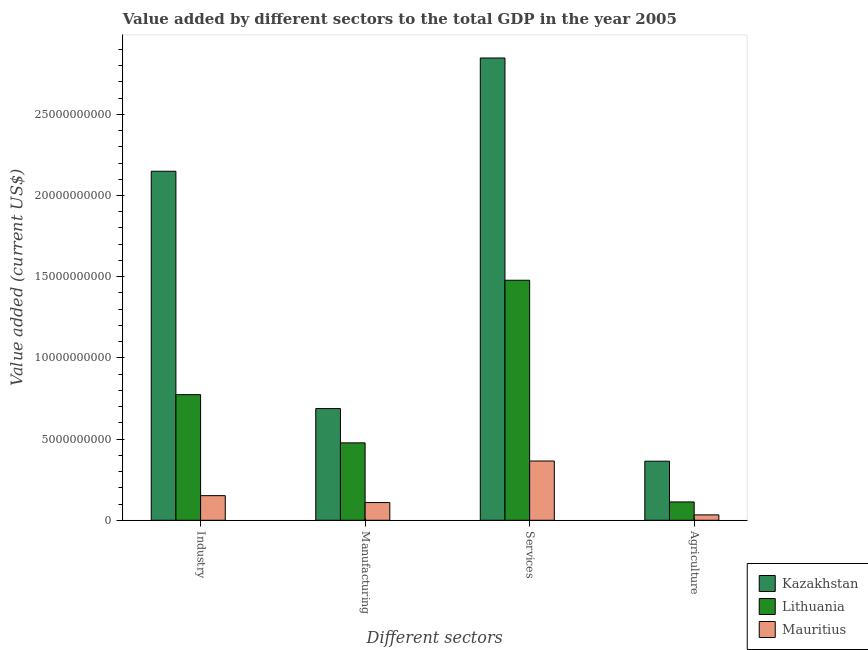Are the number of bars per tick equal to the number of legend labels?
Your answer should be very brief. Yes. Are the number of bars on each tick of the X-axis equal?
Ensure brevity in your answer.  Yes. What is the label of the 2nd group of bars from the left?
Keep it short and to the point. Manufacturing. What is the value added by manufacturing sector in Mauritius?
Keep it short and to the point. 1.09e+09. Across all countries, what is the maximum value added by services sector?
Provide a succinct answer. 2.85e+1. Across all countries, what is the minimum value added by services sector?
Give a very brief answer. 3.65e+09. In which country was the value added by industrial sector maximum?
Offer a very short reply. Kazakhstan. In which country was the value added by services sector minimum?
Provide a short and direct response. Mauritius. What is the total value added by services sector in the graph?
Your answer should be very brief. 4.69e+1. What is the difference between the value added by agricultural sector in Mauritius and that in Lithuania?
Provide a short and direct response. -7.98e+08. What is the difference between the value added by agricultural sector in Lithuania and the value added by industrial sector in Kazakhstan?
Offer a very short reply. -2.04e+1. What is the average value added by industrial sector per country?
Your answer should be compact. 1.02e+1. What is the difference between the value added by agricultural sector and value added by services sector in Kazakhstan?
Provide a succinct answer. -2.48e+1. In how many countries, is the value added by agricultural sector greater than 19000000000 US$?
Your response must be concise. 0. What is the ratio of the value added by agricultural sector in Lithuania to that in Mauritius?
Keep it short and to the point. 3.4. Is the value added by agricultural sector in Kazakhstan less than that in Lithuania?
Your response must be concise. No. What is the difference between the highest and the second highest value added by manufacturing sector?
Ensure brevity in your answer.  2.11e+09. What is the difference between the highest and the lowest value added by industrial sector?
Your answer should be compact. 2.00e+1. In how many countries, is the value added by manufacturing sector greater than the average value added by manufacturing sector taken over all countries?
Give a very brief answer. 2. Is the sum of the value added by agricultural sector in Mauritius and Kazakhstan greater than the maximum value added by manufacturing sector across all countries?
Give a very brief answer. No. Is it the case that in every country, the sum of the value added by services sector and value added by agricultural sector is greater than the sum of value added by industrial sector and value added by manufacturing sector?
Give a very brief answer. No. What does the 3rd bar from the left in Services represents?
Your answer should be very brief. Mauritius. What does the 3rd bar from the right in Manufacturing represents?
Offer a very short reply. Kazakhstan. Is it the case that in every country, the sum of the value added by industrial sector and value added by manufacturing sector is greater than the value added by services sector?
Give a very brief answer. No. How many bars are there?
Provide a succinct answer. 12. Are all the bars in the graph horizontal?
Your answer should be very brief. No. How many countries are there in the graph?
Provide a succinct answer. 3. Are the values on the major ticks of Y-axis written in scientific E-notation?
Provide a succinct answer. No. Does the graph contain any zero values?
Your answer should be compact. No. What is the title of the graph?
Ensure brevity in your answer.  Value added by different sectors to the total GDP in the year 2005. What is the label or title of the X-axis?
Offer a terse response. Different sectors. What is the label or title of the Y-axis?
Keep it short and to the point. Value added (current US$). What is the Value added (current US$) of Kazakhstan in Industry?
Give a very brief answer. 2.15e+1. What is the Value added (current US$) in Lithuania in Industry?
Offer a very short reply. 7.74e+09. What is the Value added (current US$) in Mauritius in Industry?
Your response must be concise. 1.52e+09. What is the Value added (current US$) of Kazakhstan in Manufacturing?
Provide a succinct answer. 6.88e+09. What is the Value added (current US$) in Lithuania in Manufacturing?
Ensure brevity in your answer.  4.77e+09. What is the Value added (current US$) in Mauritius in Manufacturing?
Provide a succinct answer. 1.09e+09. What is the Value added (current US$) of Kazakhstan in Services?
Your answer should be very brief. 2.85e+1. What is the Value added (current US$) of Lithuania in Services?
Offer a very short reply. 1.48e+1. What is the Value added (current US$) in Mauritius in Services?
Your response must be concise. 3.65e+09. What is the Value added (current US$) of Kazakhstan in Agriculture?
Provide a succinct answer. 3.64e+09. What is the Value added (current US$) in Lithuania in Agriculture?
Offer a terse response. 1.13e+09. What is the Value added (current US$) of Mauritius in Agriculture?
Your answer should be compact. 3.32e+08. Across all Different sectors, what is the maximum Value added (current US$) of Kazakhstan?
Provide a succinct answer. 2.85e+1. Across all Different sectors, what is the maximum Value added (current US$) in Lithuania?
Offer a very short reply. 1.48e+1. Across all Different sectors, what is the maximum Value added (current US$) of Mauritius?
Keep it short and to the point. 3.65e+09. Across all Different sectors, what is the minimum Value added (current US$) in Kazakhstan?
Your response must be concise. 3.64e+09. Across all Different sectors, what is the minimum Value added (current US$) in Lithuania?
Give a very brief answer. 1.13e+09. Across all Different sectors, what is the minimum Value added (current US$) in Mauritius?
Offer a very short reply. 3.32e+08. What is the total Value added (current US$) in Kazakhstan in the graph?
Your response must be concise. 6.05e+1. What is the total Value added (current US$) of Lithuania in the graph?
Make the answer very short. 2.84e+1. What is the total Value added (current US$) of Mauritius in the graph?
Your response must be concise. 6.59e+09. What is the difference between the Value added (current US$) in Kazakhstan in Industry and that in Manufacturing?
Offer a terse response. 1.46e+1. What is the difference between the Value added (current US$) in Lithuania in Industry and that in Manufacturing?
Offer a very short reply. 2.97e+09. What is the difference between the Value added (current US$) in Mauritius in Industry and that in Manufacturing?
Give a very brief answer. 4.25e+08. What is the difference between the Value added (current US$) in Kazakhstan in Industry and that in Services?
Provide a succinct answer. -6.98e+09. What is the difference between the Value added (current US$) in Lithuania in Industry and that in Services?
Make the answer very short. -7.05e+09. What is the difference between the Value added (current US$) in Mauritius in Industry and that in Services?
Keep it short and to the point. -2.13e+09. What is the difference between the Value added (current US$) in Kazakhstan in Industry and that in Agriculture?
Give a very brief answer. 1.79e+1. What is the difference between the Value added (current US$) in Lithuania in Industry and that in Agriculture?
Keep it short and to the point. 6.61e+09. What is the difference between the Value added (current US$) of Mauritius in Industry and that in Agriculture?
Ensure brevity in your answer.  1.18e+09. What is the difference between the Value added (current US$) of Kazakhstan in Manufacturing and that in Services?
Your answer should be compact. -2.16e+1. What is the difference between the Value added (current US$) in Lithuania in Manufacturing and that in Services?
Your response must be concise. -1.00e+1. What is the difference between the Value added (current US$) in Mauritius in Manufacturing and that in Services?
Keep it short and to the point. -2.56e+09. What is the difference between the Value added (current US$) of Kazakhstan in Manufacturing and that in Agriculture?
Provide a succinct answer. 3.24e+09. What is the difference between the Value added (current US$) in Lithuania in Manufacturing and that in Agriculture?
Keep it short and to the point. 3.64e+09. What is the difference between the Value added (current US$) in Mauritius in Manufacturing and that in Agriculture?
Make the answer very short. 7.59e+08. What is the difference between the Value added (current US$) in Kazakhstan in Services and that in Agriculture?
Provide a short and direct response. 2.48e+1. What is the difference between the Value added (current US$) in Lithuania in Services and that in Agriculture?
Make the answer very short. 1.37e+1. What is the difference between the Value added (current US$) of Mauritius in Services and that in Agriculture?
Provide a short and direct response. 3.32e+09. What is the difference between the Value added (current US$) in Kazakhstan in Industry and the Value added (current US$) in Lithuania in Manufacturing?
Offer a very short reply. 1.67e+1. What is the difference between the Value added (current US$) of Kazakhstan in Industry and the Value added (current US$) of Mauritius in Manufacturing?
Your answer should be compact. 2.04e+1. What is the difference between the Value added (current US$) in Lithuania in Industry and the Value added (current US$) in Mauritius in Manufacturing?
Your response must be concise. 6.64e+09. What is the difference between the Value added (current US$) of Kazakhstan in Industry and the Value added (current US$) of Lithuania in Services?
Provide a succinct answer. 6.71e+09. What is the difference between the Value added (current US$) in Kazakhstan in Industry and the Value added (current US$) in Mauritius in Services?
Offer a terse response. 1.78e+1. What is the difference between the Value added (current US$) of Lithuania in Industry and the Value added (current US$) of Mauritius in Services?
Your answer should be very brief. 4.09e+09. What is the difference between the Value added (current US$) of Kazakhstan in Industry and the Value added (current US$) of Lithuania in Agriculture?
Your answer should be very brief. 2.04e+1. What is the difference between the Value added (current US$) of Kazakhstan in Industry and the Value added (current US$) of Mauritius in Agriculture?
Your response must be concise. 2.12e+1. What is the difference between the Value added (current US$) of Lithuania in Industry and the Value added (current US$) of Mauritius in Agriculture?
Provide a short and direct response. 7.40e+09. What is the difference between the Value added (current US$) in Kazakhstan in Manufacturing and the Value added (current US$) in Lithuania in Services?
Your answer should be compact. -7.90e+09. What is the difference between the Value added (current US$) of Kazakhstan in Manufacturing and the Value added (current US$) of Mauritius in Services?
Keep it short and to the point. 3.23e+09. What is the difference between the Value added (current US$) of Lithuania in Manufacturing and the Value added (current US$) of Mauritius in Services?
Provide a succinct answer. 1.12e+09. What is the difference between the Value added (current US$) of Kazakhstan in Manufacturing and the Value added (current US$) of Lithuania in Agriculture?
Provide a short and direct response. 5.75e+09. What is the difference between the Value added (current US$) in Kazakhstan in Manufacturing and the Value added (current US$) in Mauritius in Agriculture?
Provide a succinct answer. 6.55e+09. What is the difference between the Value added (current US$) of Lithuania in Manufacturing and the Value added (current US$) of Mauritius in Agriculture?
Your response must be concise. 4.43e+09. What is the difference between the Value added (current US$) in Kazakhstan in Services and the Value added (current US$) in Lithuania in Agriculture?
Your response must be concise. 2.73e+1. What is the difference between the Value added (current US$) in Kazakhstan in Services and the Value added (current US$) in Mauritius in Agriculture?
Offer a terse response. 2.81e+1. What is the difference between the Value added (current US$) of Lithuania in Services and the Value added (current US$) of Mauritius in Agriculture?
Provide a short and direct response. 1.44e+1. What is the average Value added (current US$) of Kazakhstan per Different sectors?
Your response must be concise. 1.51e+1. What is the average Value added (current US$) in Lithuania per Different sectors?
Offer a very short reply. 7.10e+09. What is the average Value added (current US$) in Mauritius per Different sectors?
Provide a succinct answer. 1.65e+09. What is the difference between the Value added (current US$) in Kazakhstan and Value added (current US$) in Lithuania in Industry?
Offer a terse response. 1.38e+1. What is the difference between the Value added (current US$) in Kazakhstan and Value added (current US$) in Mauritius in Industry?
Offer a terse response. 2.00e+1. What is the difference between the Value added (current US$) in Lithuania and Value added (current US$) in Mauritius in Industry?
Your response must be concise. 6.22e+09. What is the difference between the Value added (current US$) of Kazakhstan and Value added (current US$) of Lithuania in Manufacturing?
Offer a very short reply. 2.11e+09. What is the difference between the Value added (current US$) of Kazakhstan and Value added (current US$) of Mauritius in Manufacturing?
Keep it short and to the point. 5.79e+09. What is the difference between the Value added (current US$) of Lithuania and Value added (current US$) of Mauritius in Manufacturing?
Your response must be concise. 3.68e+09. What is the difference between the Value added (current US$) of Kazakhstan and Value added (current US$) of Lithuania in Services?
Your answer should be compact. 1.37e+1. What is the difference between the Value added (current US$) of Kazakhstan and Value added (current US$) of Mauritius in Services?
Ensure brevity in your answer.  2.48e+1. What is the difference between the Value added (current US$) of Lithuania and Value added (current US$) of Mauritius in Services?
Keep it short and to the point. 1.11e+1. What is the difference between the Value added (current US$) of Kazakhstan and Value added (current US$) of Lithuania in Agriculture?
Provide a short and direct response. 2.51e+09. What is the difference between the Value added (current US$) of Kazakhstan and Value added (current US$) of Mauritius in Agriculture?
Make the answer very short. 3.31e+09. What is the difference between the Value added (current US$) in Lithuania and Value added (current US$) in Mauritius in Agriculture?
Make the answer very short. 7.98e+08. What is the ratio of the Value added (current US$) of Kazakhstan in Industry to that in Manufacturing?
Provide a succinct answer. 3.12. What is the ratio of the Value added (current US$) in Lithuania in Industry to that in Manufacturing?
Offer a terse response. 1.62. What is the ratio of the Value added (current US$) in Mauritius in Industry to that in Manufacturing?
Your answer should be compact. 1.39. What is the ratio of the Value added (current US$) in Kazakhstan in Industry to that in Services?
Your response must be concise. 0.76. What is the ratio of the Value added (current US$) of Lithuania in Industry to that in Services?
Provide a short and direct response. 0.52. What is the ratio of the Value added (current US$) in Mauritius in Industry to that in Services?
Offer a very short reply. 0.42. What is the ratio of the Value added (current US$) in Kazakhstan in Industry to that in Agriculture?
Ensure brevity in your answer.  5.91. What is the ratio of the Value added (current US$) of Lithuania in Industry to that in Agriculture?
Give a very brief answer. 6.85. What is the ratio of the Value added (current US$) of Mauritius in Industry to that in Agriculture?
Your answer should be compact. 4.57. What is the ratio of the Value added (current US$) in Kazakhstan in Manufacturing to that in Services?
Your response must be concise. 0.24. What is the ratio of the Value added (current US$) in Lithuania in Manufacturing to that in Services?
Offer a terse response. 0.32. What is the ratio of the Value added (current US$) in Mauritius in Manufacturing to that in Services?
Offer a very short reply. 0.3. What is the ratio of the Value added (current US$) of Kazakhstan in Manufacturing to that in Agriculture?
Provide a succinct answer. 1.89. What is the ratio of the Value added (current US$) of Lithuania in Manufacturing to that in Agriculture?
Your answer should be compact. 4.22. What is the ratio of the Value added (current US$) in Mauritius in Manufacturing to that in Agriculture?
Your response must be concise. 3.29. What is the ratio of the Value added (current US$) of Kazakhstan in Services to that in Agriculture?
Ensure brevity in your answer.  7.82. What is the ratio of the Value added (current US$) of Lithuania in Services to that in Agriculture?
Make the answer very short. 13.09. What is the ratio of the Value added (current US$) in Mauritius in Services to that in Agriculture?
Your answer should be compact. 11. What is the difference between the highest and the second highest Value added (current US$) in Kazakhstan?
Offer a terse response. 6.98e+09. What is the difference between the highest and the second highest Value added (current US$) in Lithuania?
Offer a terse response. 7.05e+09. What is the difference between the highest and the second highest Value added (current US$) in Mauritius?
Give a very brief answer. 2.13e+09. What is the difference between the highest and the lowest Value added (current US$) of Kazakhstan?
Offer a terse response. 2.48e+1. What is the difference between the highest and the lowest Value added (current US$) in Lithuania?
Make the answer very short. 1.37e+1. What is the difference between the highest and the lowest Value added (current US$) in Mauritius?
Your answer should be compact. 3.32e+09. 